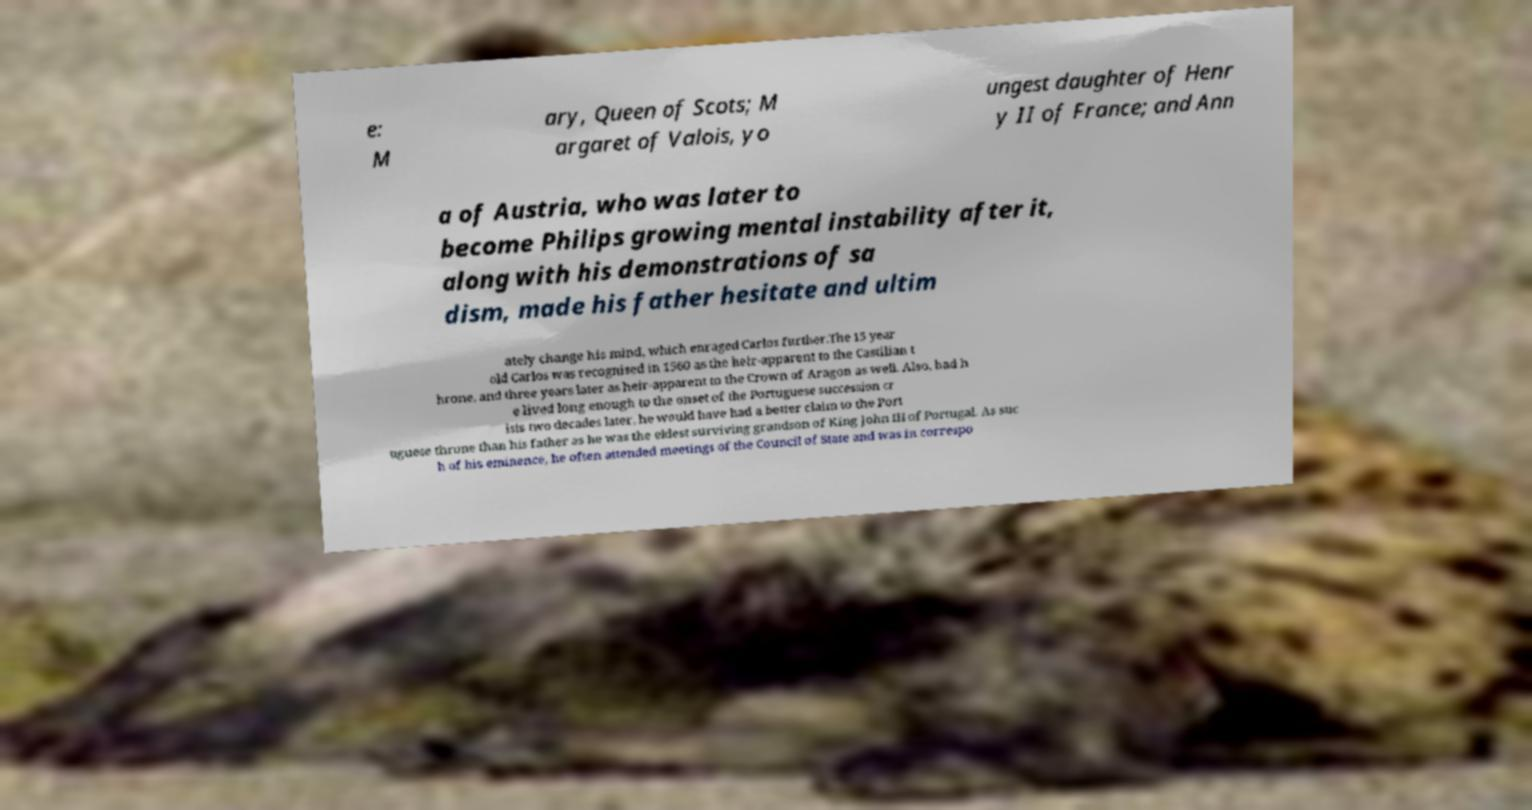What messages or text are displayed in this image? I need them in a readable, typed format. e: M ary, Queen of Scots; M argaret of Valois, yo ungest daughter of Henr y II of France; and Ann a of Austria, who was later to become Philips growing mental instability after it, along with his demonstrations of sa dism, made his father hesitate and ultim ately change his mind, which enraged Carlos further.The 15 year old Carlos was recognised in 1560 as the heir-apparent to the Castilian t hrone, and three years later as heir-apparent to the Crown of Aragon as well. Also, had h e lived long enough to the onset of the Portuguese succession cr isis two decades later, he would have had a better claim to the Port uguese throne than his father as he was the eldest surviving grandson of King John III of Portugal. As suc h of his eminence, he often attended meetings of the Council of State and was in correspo 